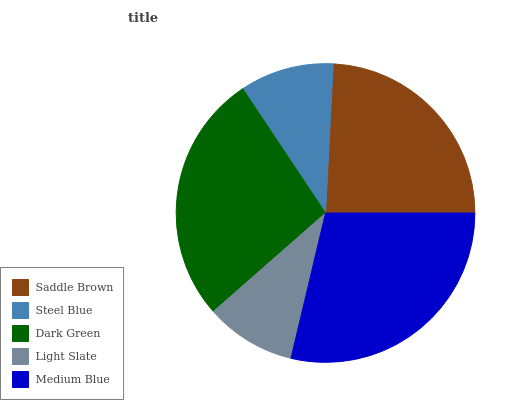Is Light Slate the minimum?
Answer yes or no. Yes. Is Medium Blue the maximum?
Answer yes or no. Yes. Is Steel Blue the minimum?
Answer yes or no. No. Is Steel Blue the maximum?
Answer yes or no. No. Is Saddle Brown greater than Steel Blue?
Answer yes or no. Yes. Is Steel Blue less than Saddle Brown?
Answer yes or no. Yes. Is Steel Blue greater than Saddle Brown?
Answer yes or no. No. Is Saddle Brown less than Steel Blue?
Answer yes or no. No. Is Saddle Brown the high median?
Answer yes or no. Yes. Is Saddle Brown the low median?
Answer yes or no. Yes. Is Dark Green the high median?
Answer yes or no. No. Is Steel Blue the low median?
Answer yes or no. No. 